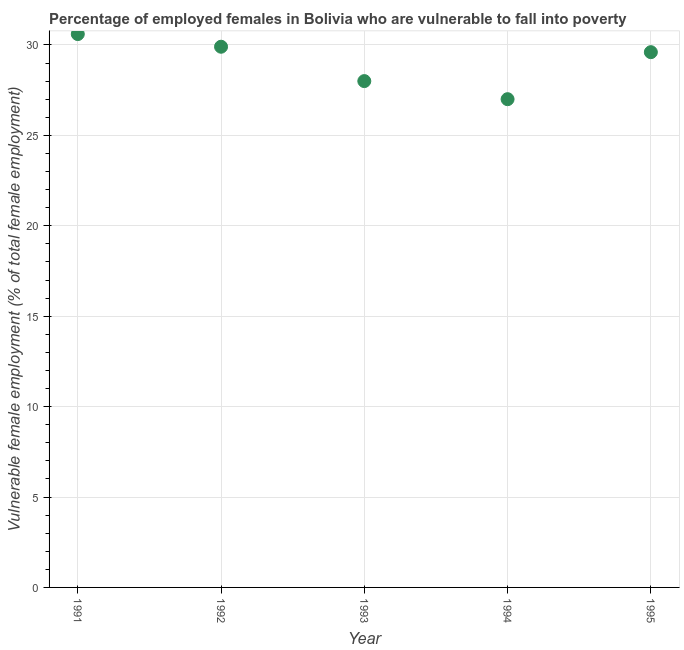What is the percentage of employed females who are vulnerable to fall into poverty in 1994?
Offer a very short reply. 27. Across all years, what is the maximum percentage of employed females who are vulnerable to fall into poverty?
Your answer should be very brief. 30.6. Across all years, what is the minimum percentage of employed females who are vulnerable to fall into poverty?
Give a very brief answer. 27. In which year was the percentage of employed females who are vulnerable to fall into poverty maximum?
Your answer should be very brief. 1991. What is the sum of the percentage of employed females who are vulnerable to fall into poverty?
Keep it short and to the point. 145.1. What is the difference between the percentage of employed females who are vulnerable to fall into poverty in 1991 and 1994?
Your answer should be very brief. 3.6. What is the average percentage of employed females who are vulnerable to fall into poverty per year?
Give a very brief answer. 29.02. What is the median percentage of employed females who are vulnerable to fall into poverty?
Offer a very short reply. 29.6. What is the ratio of the percentage of employed females who are vulnerable to fall into poverty in 1991 to that in 1993?
Make the answer very short. 1.09. What is the difference between the highest and the second highest percentage of employed females who are vulnerable to fall into poverty?
Your answer should be compact. 0.7. What is the difference between the highest and the lowest percentage of employed females who are vulnerable to fall into poverty?
Make the answer very short. 3.6. In how many years, is the percentage of employed females who are vulnerable to fall into poverty greater than the average percentage of employed females who are vulnerable to fall into poverty taken over all years?
Your answer should be compact. 3. How many dotlines are there?
Ensure brevity in your answer.  1. Are the values on the major ticks of Y-axis written in scientific E-notation?
Provide a succinct answer. No. Does the graph contain grids?
Ensure brevity in your answer.  Yes. What is the title of the graph?
Provide a short and direct response. Percentage of employed females in Bolivia who are vulnerable to fall into poverty. What is the label or title of the Y-axis?
Make the answer very short. Vulnerable female employment (% of total female employment). What is the Vulnerable female employment (% of total female employment) in 1991?
Your response must be concise. 30.6. What is the Vulnerable female employment (% of total female employment) in 1992?
Offer a very short reply. 29.9. What is the Vulnerable female employment (% of total female employment) in 1993?
Provide a short and direct response. 28. What is the Vulnerable female employment (% of total female employment) in 1995?
Ensure brevity in your answer.  29.6. What is the difference between the Vulnerable female employment (% of total female employment) in 1991 and 1994?
Your answer should be very brief. 3.6. What is the difference between the Vulnerable female employment (% of total female employment) in 1991 and 1995?
Make the answer very short. 1. What is the difference between the Vulnerable female employment (% of total female employment) in 1992 and 1994?
Ensure brevity in your answer.  2.9. What is the difference between the Vulnerable female employment (% of total female employment) in 1994 and 1995?
Make the answer very short. -2.6. What is the ratio of the Vulnerable female employment (% of total female employment) in 1991 to that in 1993?
Provide a succinct answer. 1.09. What is the ratio of the Vulnerable female employment (% of total female employment) in 1991 to that in 1994?
Offer a very short reply. 1.13. What is the ratio of the Vulnerable female employment (% of total female employment) in 1991 to that in 1995?
Your response must be concise. 1.03. What is the ratio of the Vulnerable female employment (% of total female employment) in 1992 to that in 1993?
Provide a short and direct response. 1.07. What is the ratio of the Vulnerable female employment (% of total female employment) in 1992 to that in 1994?
Provide a short and direct response. 1.11. What is the ratio of the Vulnerable female employment (% of total female employment) in 1992 to that in 1995?
Offer a very short reply. 1.01. What is the ratio of the Vulnerable female employment (% of total female employment) in 1993 to that in 1995?
Your answer should be compact. 0.95. What is the ratio of the Vulnerable female employment (% of total female employment) in 1994 to that in 1995?
Your answer should be compact. 0.91. 